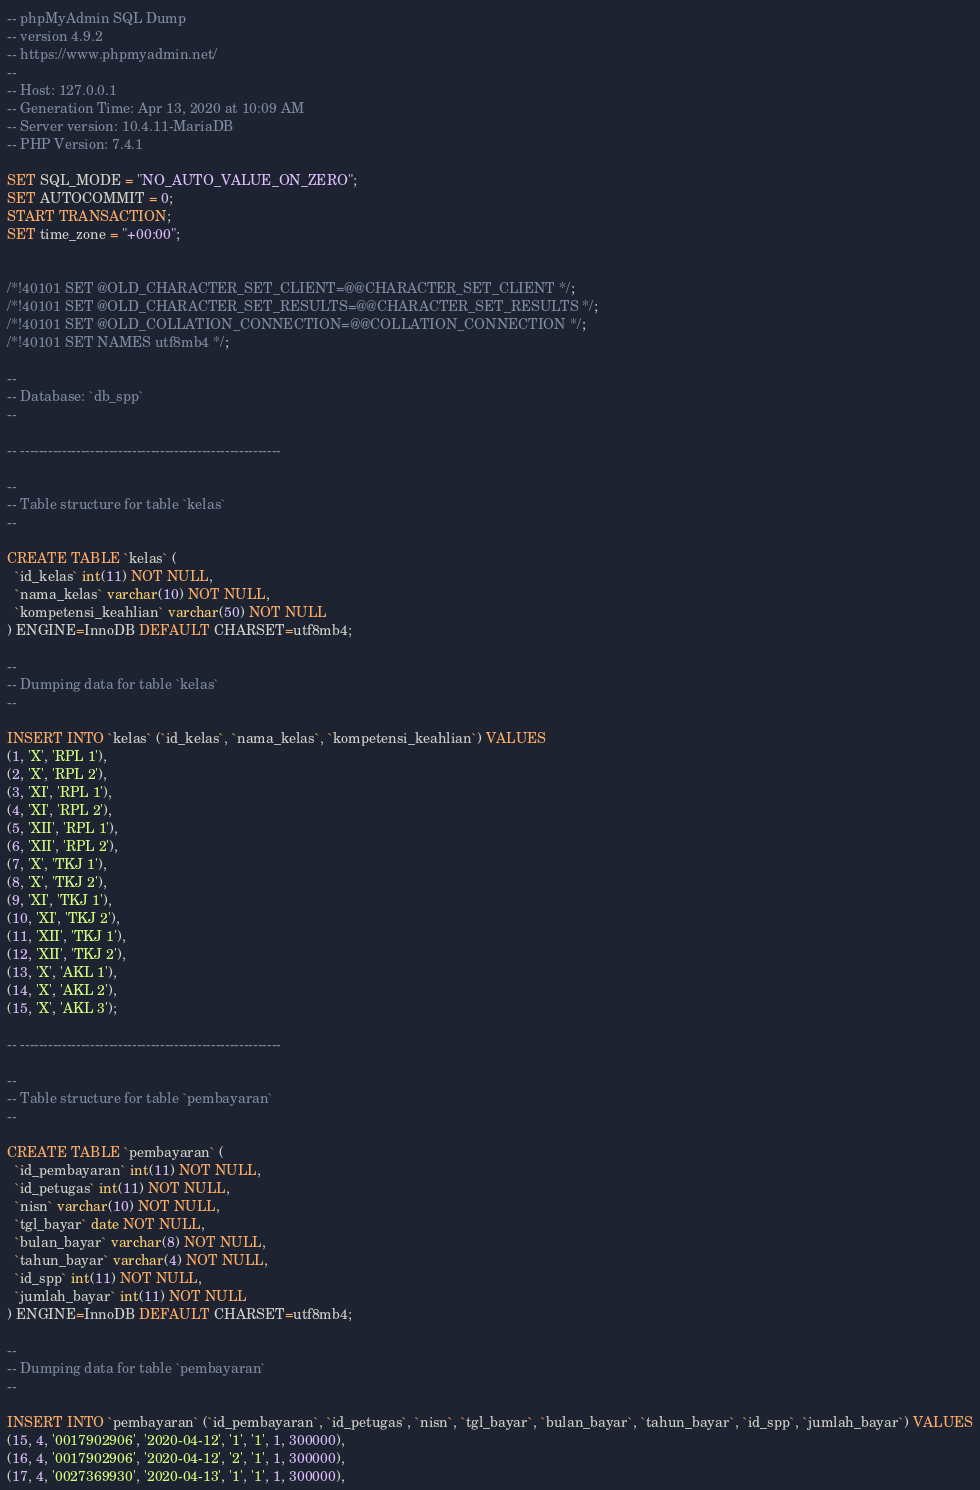<code> <loc_0><loc_0><loc_500><loc_500><_SQL_>-- phpMyAdmin SQL Dump
-- version 4.9.2
-- https://www.phpmyadmin.net/
--
-- Host: 127.0.0.1
-- Generation Time: Apr 13, 2020 at 10:09 AM
-- Server version: 10.4.11-MariaDB
-- PHP Version: 7.4.1

SET SQL_MODE = "NO_AUTO_VALUE_ON_ZERO";
SET AUTOCOMMIT = 0;
START TRANSACTION;
SET time_zone = "+00:00";


/*!40101 SET @OLD_CHARACTER_SET_CLIENT=@@CHARACTER_SET_CLIENT */;
/*!40101 SET @OLD_CHARACTER_SET_RESULTS=@@CHARACTER_SET_RESULTS */;
/*!40101 SET @OLD_COLLATION_CONNECTION=@@COLLATION_CONNECTION */;
/*!40101 SET NAMES utf8mb4 */;

--
-- Database: `db_spp`
--

-- --------------------------------------------------------

--
-- Table structure for table `kelas`
--

CREATE TABLE `kelas` (
  `id_kelas` int(11) NOT NULL,
  `nama_kelas` varchar(10) NOT NULL,
  `kompetensi_keahlian` varchar(50) NOT NULL
) ENGINE=InnoDB DEFAULT CHARSET=utf8mb4;

--
-- Dumping data for table `kelas`
--

INSERT INTO `kelas` (`id_kelas`, `nama_kelas`, `kompetensi_keahlian`) VALUES
(1, 'X', 'RPL 1'),
(2, 'X', 'RPL 2'),
(3, 'XI', 'RPL 1'),
(4, 'XI', 'RPL 2'),
(5, 'XII', 'RPL 1'),
(6, 'XII', 'RPL 2'),
(7, 'X', 'TKJ 1'),
(8, 'X', 'TKJ 2'),
(9, 'XI', 'TKJ 1'),
(10, 'XI', 'TKJ 2'),
(11, 'XII', 'TKJ 1'),
(12, 'XII', 'TKJ 2'),
(13, 'X', 'AKL 1'),
(14, 'X', 'AKL 2'),
(15, 'X', 'AKL 3');

-- --------------------------------------------------------

--
-- Table structure for table `pembayaran`
--

CREATE TABLE `pembayaran` (
  `id_pembayaran` int(11) NOT NULL,
  `id_petugas` int(11) NOT NULL,
  `nisn` varchar(10) NOT NULL,
  `tgl_bayar` date NOT NULL,
  `bulan_bayar` varchar(8) NOT NULL,
  `tahun_bayar` varchar(4) NOT NULL,
  `id_spp` int(11) NOT NULL,
  `jumlah_bayar` int(11) NOT NULL
) ENGINE=InnoDB DEFAULT CHARSET=utf8mb4;

--
-- Dumping data for table `pembayaran`
--

INSERT INTO `pembayaran` (`id_pembayaran`, `id_petugas`, `nisn`, `tgl_bayar`, `bulan_bayar`, `tahun_bayar`, `id_spp`, `jumlah_bayar`) VALUES
(15, 4, '0017902906', '2020-04-12', '1', '1', 1, 300000),
(16, 4, '0017902906', '2020-04-12', '2', '1', 1, 300000),
(17, 4, '0027369930', '2020-04-13', '1', '1', 1, 300000),</code> 